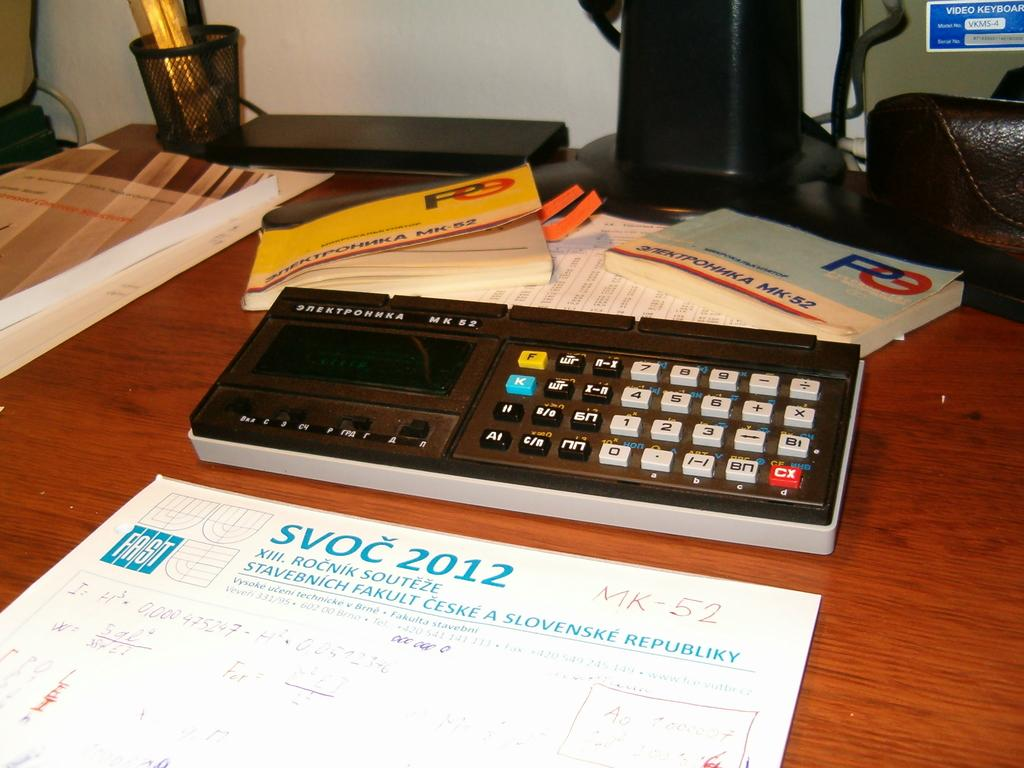Provide a one-sentence caption for the provided image. A desk with a calculator and some books about MK-52 and a notepad about Slovenske Republiky. 